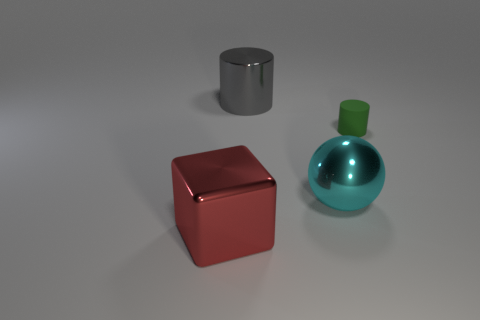Add 3 big green metallic things. How many objects exist? 7 Subtract all green cylinders. How many cylinders are left? 1 Subtract all balls. How many objects are left? 3 Subtract 0 brown blocks. How many objects are left? 4 Subtract all yellow balls. Subtract all blue cubes. How many balls are left? 1 Subtract all gray metallic things. Subtract all large cubes. How many objects are left? 2 Add 3 big red metallic cubes. How many big red metallic cubes are left? 4 Add 2 small gray rubber balls. How many small gray rubber balls exist? 2 